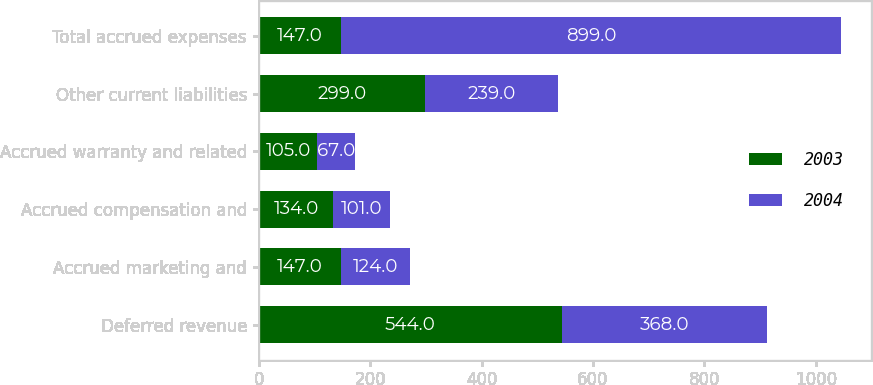Convert chart to OTSL. <chart><loc_0><loc_0><loc_500><loc_500><stacked_bar_chart><ecel><fcel>Deferred revenue<fcel>Accrued marketing and<fcel>Accrued compensation and<fcel>Accrued warranty and related<fcel>Other current liabilities<fcel>Total accrued expenses<nl><fcel>2003<fcel>544<fcel>147<fcel>134<fcel>105<fcel>299<fcel>147<nl><fcel>2004<fcel>368<fcel>124<fcel>101<fcel>67<fcel>239<fcel>899<nl></chart> 